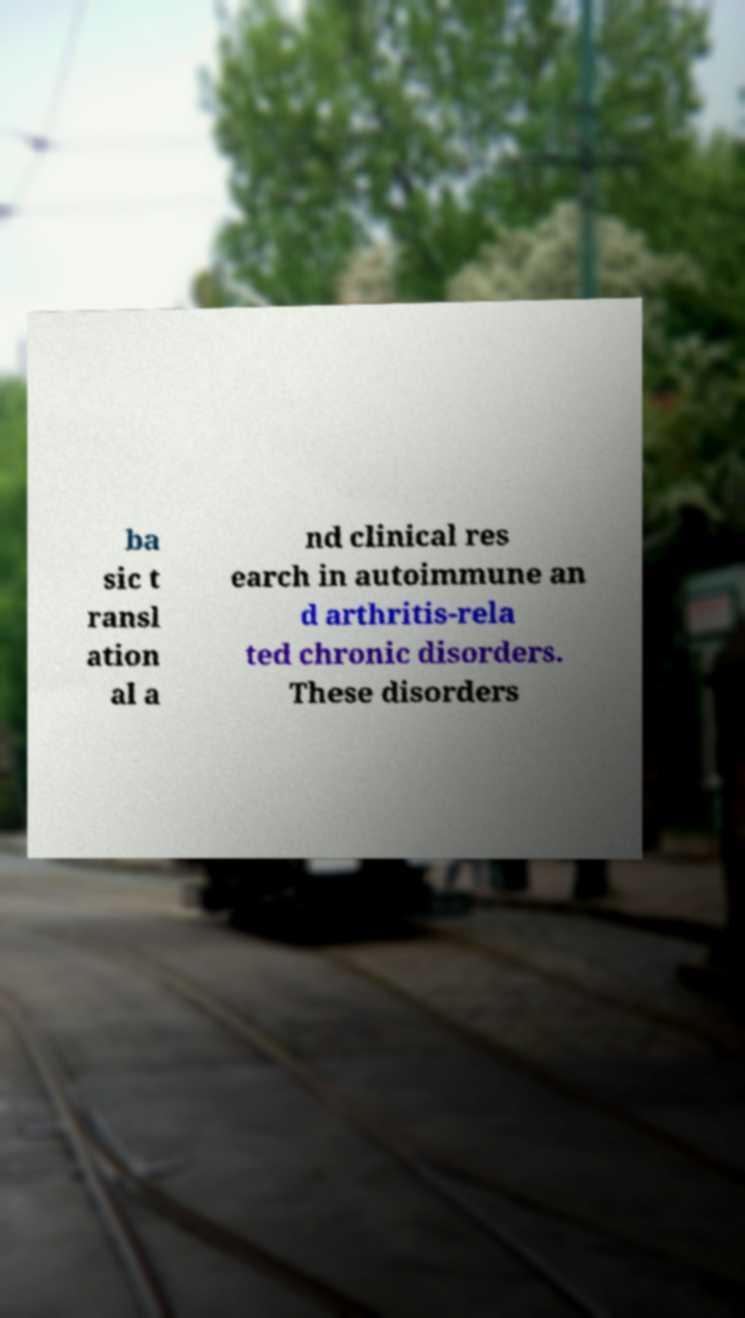What messages or text are displayed in this image? I need them in a readable, typed format. ba sic t ransl ation al a nd clinical res earch in autoimmune an d arthritis-rela ted chronic disorders. These disorders 